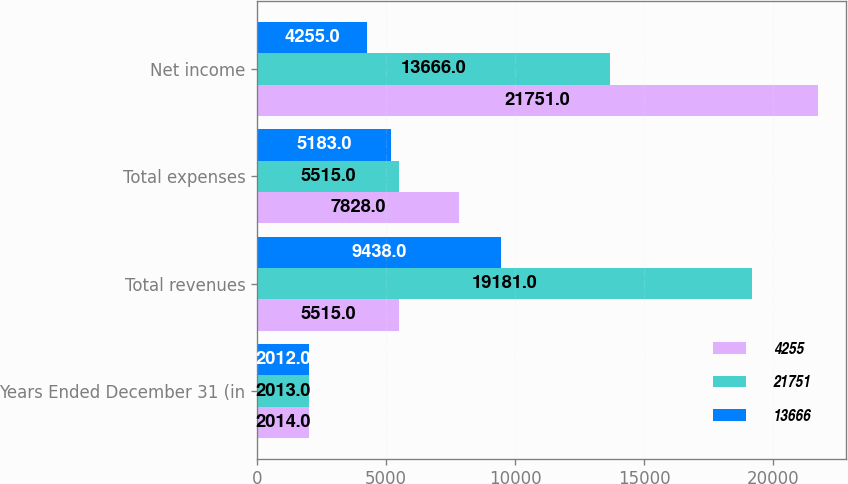<chart> <loc_0><loc_0><loc_500><loc_500><stacked_bar_chart><ecel><fcel>Years Ended December 31 (in<fcel>Total revenues<fcel>Total expenses<fcel>Net income<nl><fcel>4255<fcel>2014<fcel>5515<fcel>7828<fcel>21751<nl><fcel>21751<fcel>2013<fcel>19181<fcel>5515<fcel>13666<nl><fcel>13666<fcel>2012<fcel>9438<fcel>5183<fcel>4255<nl></chart> 